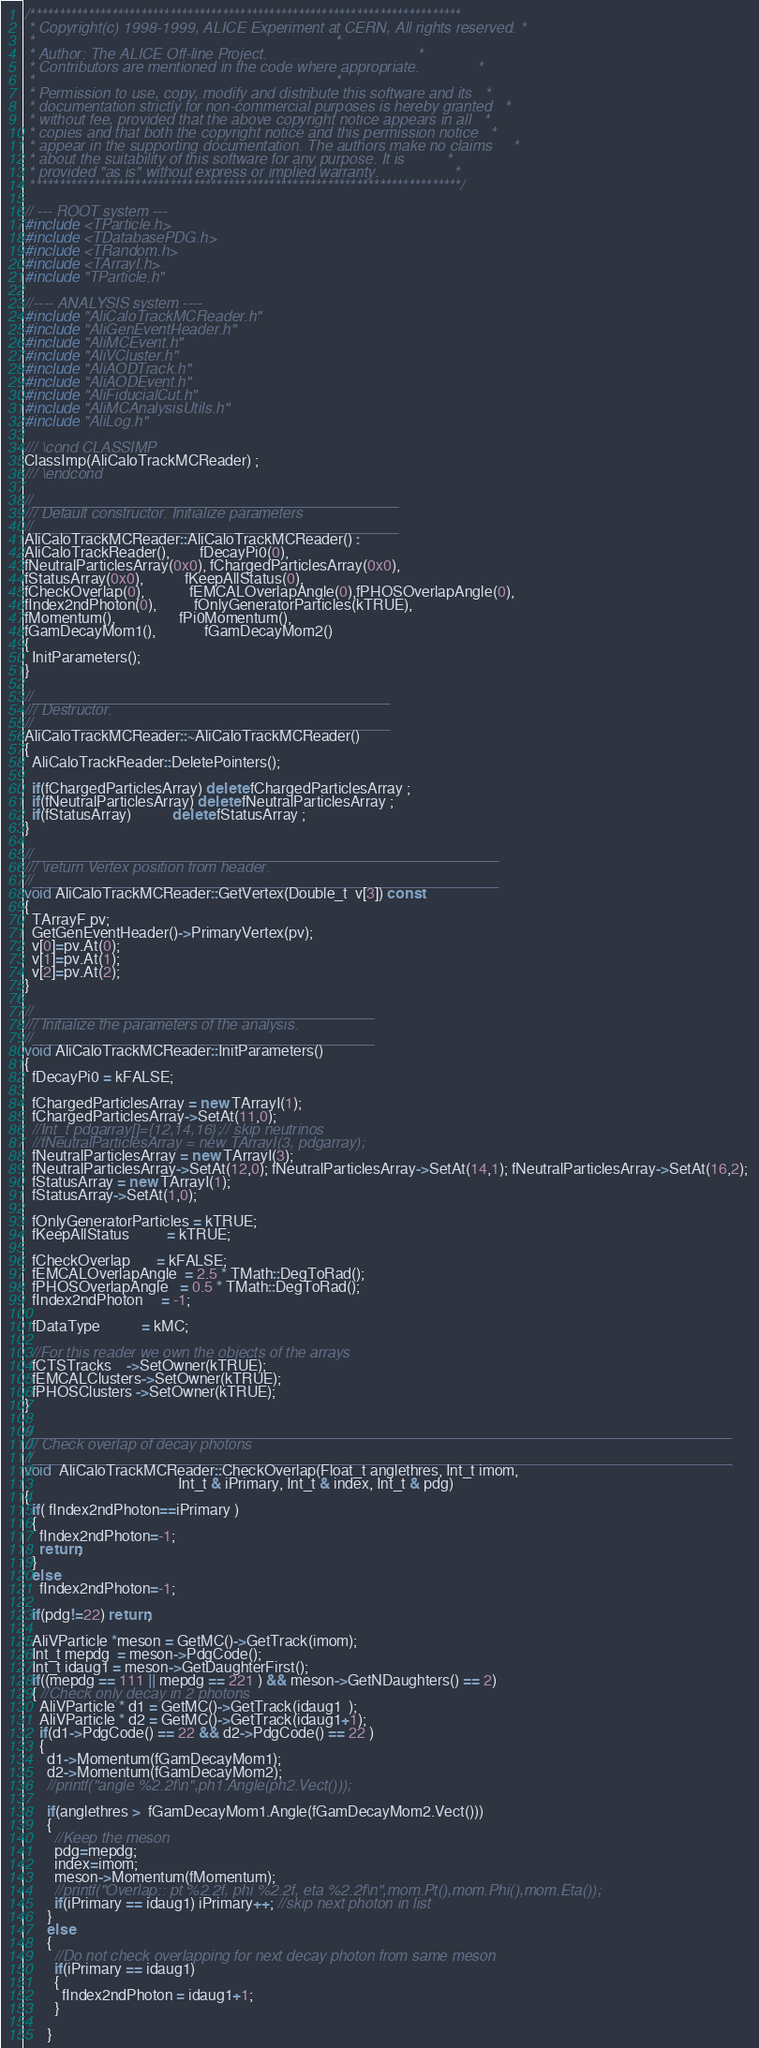Convert code to text. <code><loc_0><loc_0><loc_500><loc_500><_C++_>/**************************************************************************
 * Copyright(c) 1998-1999, ALICE Experiment at CERN, All rights reserved. *
 *                                                                        *
 * Author: The ALICE Off-line Project.                                    *
 * Contributors are mentioned in the code where appropriate.              *
 *                                                                        *
 * Permission to use, copy, modify and distribute this software and its   *
 * documentation strictly for non-commercial purposes is hereby granted   *
 * without fee, provided that the above copyright notice appears in all   *
 * copies and that both the copyright notice and this permission notice   *
 * appear in the supporting documentation. The authors make no claims     *
 * about the suitability of this software for any purpose. It is          *
 * provided "as is" without express or implied warranty.                  *
 **************************************************************************/

// --- ROOT system ---
#include <TParticle.h>
#include <TDatabasePDG.h>
#include <TRandom.h>
#include <TArrayI.h>
#include "TParticle.h"

//---- ANALYSIS system ----
#include "AliCaloTrackMCReader.h" 
#include "AliGenEventHeader.h"
#include "AliMCEvent.h"
#include "AliVCluster.h"
#include "AliAODTrack.h"
#include "AliAODEvent.h"
#include "AliFiducialCut.h"
#include "AliMCAnalysisUtils.h"
#include "AliLog.h"

/// \cond CLASSIMP
ClassImp(AliCaloTrackMCReader) ;
/// \endcond 

//____________________________________________
/// Default constructor. Initialize parameters
//____________________________________________
AliCaloTrackMCReader::AliCaloTrackMCReader() : 
AliCaloTrackReader(),        fDecayPi0(0), 
fNeutralParticlesArray(0x0), fChargedParticlesArray(0x0), 
fStatusArray(0x0),           fKeepAllStatus(0), 
fCheckOverlap(0),            fEMCALOverlapAngle(0),fPHOSOverlapAngle(0), 
fIndex2ndPhoton(0),          fOnlyGeneratorParticles(kTRUE),
fMomentum(),                 fPi0Momentum(),
fGamDecayMom1(),             fGamDecayMom2()
{
  InitParameters();
}

//___________________________________________
/// Destructor.
//___________________________________________
AliCaloTrackMCReader::~AliCaloTrackMCReader()
{
  AliCaloTrackReader::DeletePointers();

  if(fChargedParticlesArray) delete fChargedParticlesArray ;
  if(fNeutralParticlesArray) delete fNeutralParticlesArray ;
  if(fStatusArray)           delete fStatusArray ;
}

//________________________________________________________
/// \return Vertex position from header.
//________________________________________________________
void AliCaloTrackMCReader::GetVertex(Double_t  v[3]) const 
{  
  TArrayF pv;
  GetGenEventHeader()->PrimaryVertex(pv);
  v[0]=pv.At(0);
  v[1]=pv.At(1);
  v[2]=pv.At(2);
}

//_________________________________________
/// Initialize the parameters of the analysis.
//_________________________________________
void AliCaloTrackMCReader::InitParameters()
{
  fDecayPi0 = kFALSE;
  
  fChargedParticlesArray = new TArrayI(1);
  fChargedParticlesArray->SetAt(11,0);  
  //Int_t pdgarray[]={12,14,16};// skip neutrinos
  //fNeutralParticlesArray = new TArrayI(3, pdgarray);
  fNeutralParticlesArray = new TArrayI(3);
  fNeutralParticlesArray->SetAt(12,0); fNeutralParticlesArray->SetAt(14,1); fNeutralParticlesArray->SetAt(16,2); 
  fStatusArray = new TArrayI(1);
  fStatusArray->SetAt(1,0); 
  
  fOnlyGeneratorParticles = kTRUE;
  fKeepAllStatus          = kTRUE;
  
  fCheckOverlap       = kFALSE;
  fEMCALOverlapAngle  = 2.5 * TMath::DegToRad();
  fPHOSOverlapAngle   = 0.5 * TMath::DegToRad();
  fIndex2ndPhoton     = -1;
  
  fDataType           = kMC;  
  
  //For this reader we own the objects of the arrays
  fCTSTracks    ->SetOwner(kTRUE); 
  fEMCALClusters->SetOwner(kTRUE); 
  fPHOSClusters ->SetOwner(kTRUE); 
}

//____________________________________________________________________________________
/// Check overlap of decay photons
//____________________________________________________________________________________
void  AliCaloTrackMCReader::CheckOverlap(Float_t anglethres, Int_t imom,
                                         Int_t & iPrimary, Int_t & index, Int_t & pdg)
{
  if( fIndex2ndPhoton==iPrimary )
  {
    fIndex2ndPhoton=-1;
    return;
  }
  else 
    fIndex2ndPhoton=-1;
  
  if(pdg!=22) return;
  
  AliVParticle *meson = GetMC()->GetTrack(imom);
  Int_t mepdg  = meson->PdgCode();
  Int_t idaug1 = meson->GetDaughterFirst();
  if((mepdg == 111 || mepdg == 221 ) && meson->GetNDaughters() == 2)
  { //Check only decay in 2 photons
    AliVParticle * d1 = GetMC()->GetTrack(idaug1  );
    AliVParticle * d2 = GetMC()->GetTrack(idaug1+1);
    if(d1->PdgCode() == 22 && d2->PdgCode() == 22 )
    {
      d1->Momentum(fGamDecayMom1);
      d2->Momentum(fGamDecayMom2);
      //printf("angle %2.2f\n",ph1.Angle(ph2.Vect()));
      
      if(anglethres >  fGamDecayMom1.Angle(fGamDecayMom2.Vect()))
      { 	  
        //Keep the meson
        pdg=mepdg;
        index=imom;
        meson->Momentum(fMomentum);
        //printf("Overlap:: pt %2.2f, phi %2.2f, eta %2.2f\n",mom.Pt(),mom.Phi(),mom.Eta());
        if(iPrimary == idaug1) iPrimary++; //skip next photon in list
      }
      else
      {
        //Do not check overlapping for next decay photon from same meson
        if(iPrimary == idaug1)
        {
          fIndex2ndPhoton = idaug1+1;
        }
        
      }</code> 